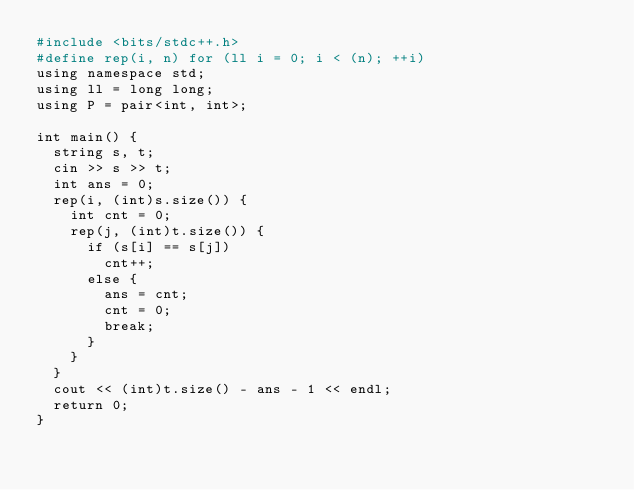Convert code to text. <code><loc_0><loc_0><loc_500><loc_500><_dc_>#include <bits/stdc++.h>
#define rep(i, n) for (ll i = 0; i < (n); ++i)
using namespace std;
using ll = long long;
using P = pair<int, int>;

int main() {
  string s, t;
  cin >> s >> t;
  int ans = 0;
  rep(i, (int)s.size()) {
    int cnt = 0;
    rep(j, (int)t.size()) {
      if (s[i] == s[j])
        cnt++;
      else {
        ans = cnt;
        cnt = 0;
        break;
      }
    }
  }
  cout << (int)t.size() - ans - 1 << endl;
  return 0;
}
</code> 